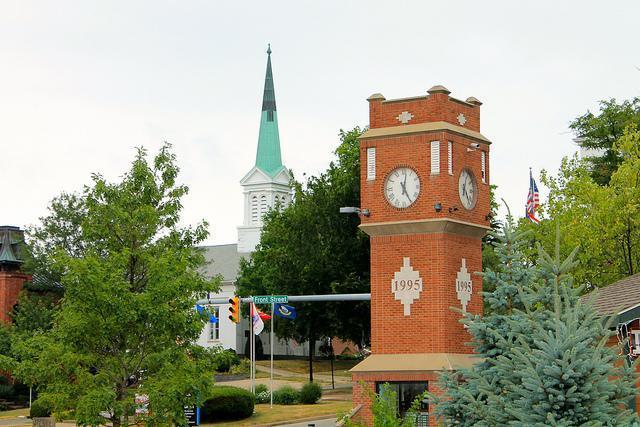How many clocks are on the building?
Give a very brief answer. 4. 